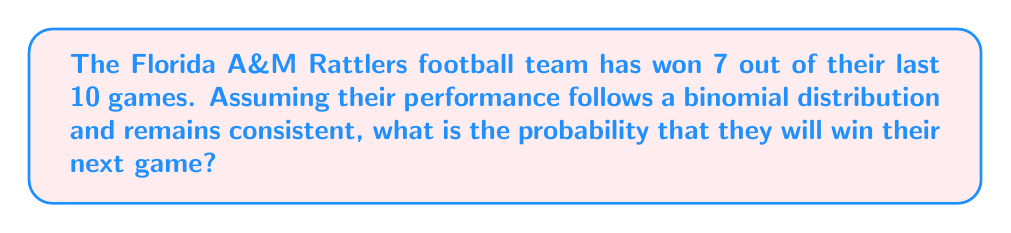Could you help me with this problem? To solve this problem, we need to use the concept of probability based on past performance. We'll treat each game as an independent event and use the binomial distribution to model the team's performance.

Given:
- The Rattlers have won 7 out of their last 10 games.
- We assume their performance follows a binomial distribution.

Step 1: Calculate the probability of winning a single game based on past performance.
$p = \frac{\text{number of wins}}{\text{total number of games}} = \frac{7}{10} = 0.7$

Step 2: Since we're only interested in the next game (a single trial), we can use the probability directly.

The probability of winning the next game is equal to the probability of winning any single game, which is 0.7 or 70%.

In terms of the binomial distribution, this can be expressed as:

$P(X = 1) = \binom{1}{1} p^1 (1-p)^{1-1} = 1 \cdot 0.7^1 \cdot 0.3^0 = 0.7$

Where:
$X$ is the random variable representing the number of wins
$n = 1$ (we're only considering one game)
$p = 0.7$ (the probability of winning a single game)

Therefore, the probability of the Florida A&M Rattlers winning their next game, based on their past performance, is 0.7 or 70%.
Answer: $0.7$ or $70\%$ 